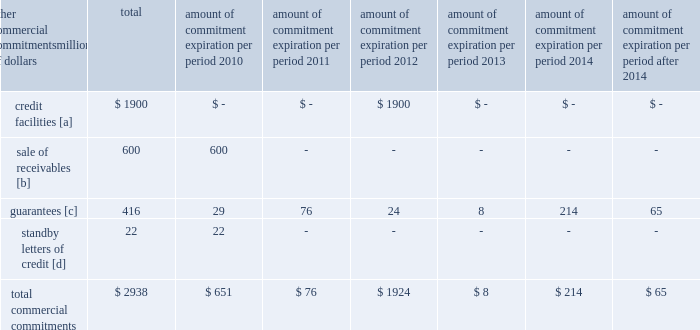Amount of commitment expiration per period other commercial commitments after millions of dollars total 2010 2011 2012 2013 2014 2014 .
[a] none of the credit facility was used as of december 31 , 2009 .
[b] $ 400 million of the sale of receivables program was utilized at december 31 , 2009 .
[c] includes guaranteed obligations related to our headquarters building , equipment financings , and affiliated operations .
[d] none of the letters of credit were drawn upon as of december 31 , 2009 .
Off-balance sheet arrangements sale of receivables 2013 the railroad transfers most of its accounts receivable to union pacific receivables , inc .
( upri ) , a bankruptcy-remote subsidiary , as part of a sale of receivables facility .
Upri sells , without recourse on a 364-day revolving basis , an undivided interest in such accounts receivable to investors .
The total capacity to sell undivided interests to investors under the facility was $ 600 million and $ 700 million at december 31 , 2009 and 2008 , respectively .
The value of the outstanding undivided interest held by investors under the facility was $ 400 million and $ 584 million at december 31 , 2009 and 2008 , respectively .
During 2009 , upri reduced the outstanding undivided interest held by investors due to a decrease in available receivables .
The value of the undivided interest held by investors is not included in our consolidated financial statements .
The value of the undivided interest held by investors was supported by $ 817 million and $ 1015 million of accounts receivable held by upri at december 31 , 2009 and 2008 , respectively .
At december 31 , 2009 and 2008 , the value of the interest retained by upri was $ 417 million and $ 431 million , respectively .
This retained interest is included in accounts receivable in our consolidated financial statements .
The interest sold to investors is sold at carrying value , which approximates fair value , and there is no gain or loss recognized from the transaction .
The value of the outstanding undivided interest held by investors could fluctuate based upon the availability of eligible receivables and is directly affected by changing business volumes and credit risks , including default and dilution .
If default or dilution ratios increase one percent , the value of the outstanding undivided interest held by investors would not change as of december 31 , 2009 .
Should our credit rating fall below investment grade , the value of the outstanding undivided interest held by investors would be reduced , and , in certain cases , the investors would have the right to discontinue the facility .
The railroad services the sold receivables ; however , the railroad does not recognize any servicing asset or liability , as the servicing fees adequately compensate us for these responsibilities .
The railroad collected approximately $ 13.8 billion and $ 17.8 billion during the years ended december 31 , 2009 and 2008 , respectively .
Upri used certain of these proceeds to purchase new receivables under the facility .
The costs of the sale of receivables program are included in other income and were $ 9 million , $ 23 million , and $ 35 million for 2009 , 2008 , and 2007 , respectively .
The costs include interest , which will vary based on prevailing commercial paper rates , program fees paid to banks , commercial paper issuing costs , and fees for unused commitment availability .
The decrease in the 2009 costs was primarily attributable to lower commercial paper rates and a decrease in the outstanding interest held by investors. .
Using the value of the undivided interest held by investors and retained by upri at december 31 , 2009 as a proxy for ar balance , what was the average receivable turnover in 2009?\\n\\n[14] : at december 31 , 2009 and 2008 , the value of the interest retained by upri was $ 417 million and $ 431 million , respectively .? 
Rationale: total amount collected during 2009 divided by year end balance = turnover
Computations: ((13.8 * 1000) / (417 + 817))
Answer: 11.18314. Amount of commitment expiration per period other commercial commitments after millions of dollars total 2010 2011 2012 2013 2014 2014 .
[a] none of the credit facility was used as of december 31 , 2009 .
[b] $ 400 million of the sale of receivables program was utilized at december 31 , 2009 .
[c] includes guaranteed obligations related to our headquarters building , equipment financings , and affiliated operations .
[d] none of the letters of credit were drawn upon as of december 31 , 2009 .
Off-balance sheet arrangements sale of receivables 2013 the railroad transfers most of its accounts receivable to union pacific receivables , inc .
( upri ) , a bankruptcy-remote subsidiary , as part of a sale of receivables facility .
Upri sells , without recourse on a 364-day revolving basis , an undivided interest in such accounts receivable to investors .
The total capacity to sell undivided interests to investors under the facility was $ 600 million and $ 700 million at december 31 , 2009 and 2008 , respectively .
The value of the outstanding undivided interest held by investors under the facility was $ 400 million and $ 584 million at december 31 , 2009 and 2008 , respectively .
During 2009 , upri reduced the outstanding undivided interest held by investors due to a decrease in available receivables .
The value of the undivided interest held by investors is not included in our consolidated financial statements .
The value of the undivided interest held by investors was supported by $ 817 million and $ 1015 million of accounts receivable held by upri at december 31 , 2009 and 2008 , respectively .
At december 31 , 2009 and 2008 , the value of the interest retained by upri was $ 417 million and $ 431 million , respectively .
This retained interest is included in accounts receivable in our consolidated financial statements .
The interest sold to investors is sold at carrying value , which approximates fair value , and there is no gain or loss recognized from the transaction .
The value of the outstanding undivided interest held by investors could fluctuate based upon the availability of eligible receivables and is directly affected by changing business volumes and credit risks , including default and dilution .
If default or dilution ratios increase one percent , the value of the outstanding undivided interest held by investors would not change as of december 31 , 2009 .
Should our credit rating fall below investment grade , the value of the outstanding undivided interest held by investors would be reduced , and , in certain cases , the investors would have the right to discontinue the facility .
The railroad services the sold receivables ; however , the railroad does not recognize any servicing asset or liability , as the servicing fees adequately compensate us for these responsibilities .
The railroad collected approximately $ 13.8 billion and $ 17.8 billion during the years ended december 31 , 2009 and 2008 , respectively .
Upri used certain of these proceeds to purchase new receivables under the facility .
The costs of the sale of receivables program are included in other income and were $ 9 million , $ 23 million , and $ 35 million for 2009 , 2008 , and 2007 , respectively .
The costs include interest , which will vary based on prevailing commercial paper rates , program fees paid to banks , commercial paper issuing costs , and fees for unused commitment availability .
The decrease in the 2009 costs was primarily attributable to lower commercial paper rates and a decrease in the outstanding interest held by investors. .
How much of the receivables facility was utilized at december 31 , 2009? 
Computations: (400 / 600)
Answer: 0.66667. 